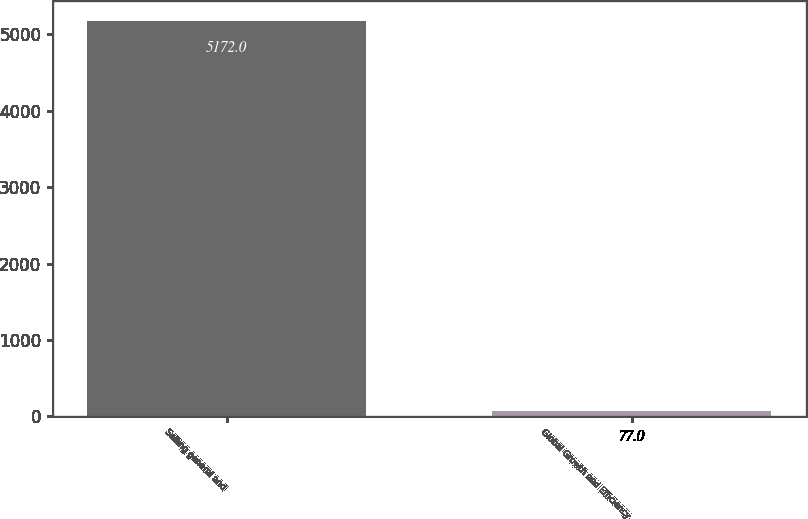Convert chart. <chart><loc_0><loc_0><loc_500><loc_500><bar_chart><fcel>Selling general and<fcel>Global Growth and Efficiency<nl><fcel>5172<fcel>77<nl></chart> 